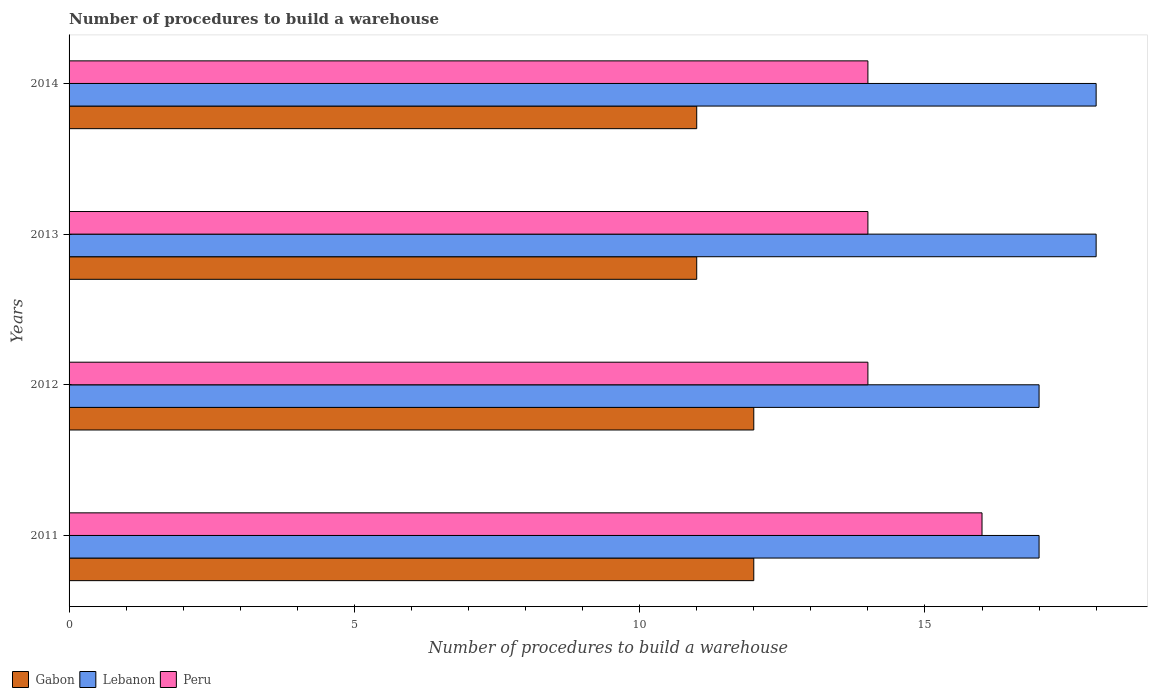How many different coloured bars are there?
Offer a terse response. 3. Are the number of bars per tick equal to the number of legend labels?
Offer a terse response. Yes. Are the number of bars on each tick of the Y-axis equal?
Your answer should be very brief. Yes. How many bars are there on the 3rd tick from the top?
Offer a very short reply. 3. How many bars are there on the 2nd tick from the bottom?
Make the answer very short. 3. What is the number of procedures to build a warehouse in in Gabon in 2012?
Offer a terse response. 12. Across all years, what is the maximum number of procedures to build a warehouse in in Gabon?
Offer a terse response. 12. Across all years, what is the minimum number of procedures to build a warehouse in in Lebanon?
Ensure brevity in your answer.  17. In which year was the number of procedures to build a warehouse in in Lebanon maximum?
Make the answer very short. 2013. In which year was the number of procedures to build a warehouse in in Gabon minimum?
Offer a very short reply. 2013. What is the total number of procedures to build a warehouse in in Lebanon in the graph?
Offer a very short reply. 70. What is the difference between the number of procedures to build a warehouse in in Lebanon in 2011 and that in 2013?
Make the answer very short. -1. What is the difference between the number of procedures to build a warehouse in in Lebanon in 2014 and the number of procedures to build a warehouse in in Peru in 2012?
Your response must be concise. 4. In the year 2013, what is the difference between the number of procedures to build a warehouse in in Lebanon and number of procedures to build a warehouse in in Gabon?
Provide a succinct answer. 7. In how many years, is the number of procedures to build a warehouse in in Gabon greater than 2 ?
Offer a very short reply. 4. What is the ratio of the number of procedures to build a warehouse in in Lebanon in 2013 to that in 2014?
Your answer should be compact. 1. Is the difference between the number of procedures to build a warehouse in in Lebanon in 2012 and 2013 greater than the difference between the number of procedures to build a warehouse in in Gabon in 2012 and 2013?
Your answer should be very brief. No. What is the difference between the highest and the lowest number of procedures to build a warehouse in in Gabon?
Keep it short and to the point. 1. In how many years, is the number of procedures to build a warehouse in in Lebanon greater than the average number of procedures to build a warehouse in in Lebanon taken over all years?
Offer a terse response. 2. Is the sum of the number of procedures to build a warehouse in in Peru in 2011 and 2013 greater than the maximum number of procedures to build a warehouse in in Gabon across all years?
Ensure brevity in your answer.  Yes. What does the 2nd bar from the top in 2012 represents?
Your response must be concise. Lebanon. How many bars are there?
Make the answer very short. 12. Are all the bars in the graph horizontal?
Provide a succinct answer. Yes. How many years are there in the graph?
Your answer should be compact. 4. What is the difference between two consecutive major ticks on the X-axis?
Your answer should be compact. 5. How are the legend labels stacked?
Your answer should be very brief. Horizontal. What is the title of the graph?
Make the answer very short. Number of procedures to build a warehouse. Does "Swaziland" appear as one of the legend labels in the graph?
Offer a terse response. No. What is the label or title of the X-axis?
Ensure brevity in your answer.  Number of procedures to build a warehouse. What is the Number of procedures to build a warehouse in Lebanon in 2013?
Provide a succinct answer. 18. What is the Number of procedures to build a warehouse of Peru in 2013?
Your response must be concise. 14. What is the Number of procedures to build a warehouse in Gabon in 2014?
Your response must be concise. 11. What is the Number of procedures to build a warehouse in Lebanon in 2014?
Provide a short and direct response. 18. Across all years, what is the maximum Number of procedures to build a warehouse in Gabon?
Make the answer very short. 12. Across all years, what is the minimum Number of procedures to build a warehouse of Gabon?
Your answer should be very brief. 11. Across all years, what is the minimum Number of procedures to build a warehouse in Peru?
Ensure brevity in your answer.  14. What is the difference between the Number of procedures to build a warehouse of Lebanon in 2011 and that in 2012?
Ensure brevity in your answer.  0. What is the difference between the Number of procedures to build a warehouse of Peru in 2011 and that in 2012?
Ensure brevity in your answer.  2. What is the difference between the Number of procedures to build a warehouse in Gabon in 2011 and that in 2013?
Offer a terse response. 1. What is the difference between the Number of procedures to build a warehouse in Lebanon in 2011 and that in 2013?
Your answer should be very brief. -1. What is the difference between the Number of procedures to build a warehouse of Peru in 2011 and that in 2013?
Keep it short and to the point. 2. What is the difference between the Number of procedures to build a warehouse of Lebanon in 2011 and that in 2014?
Offer a terse response. -1. What is the difference between the Number of procedures to build a warehouse of Lebanon in 2012 and that in 2013?
Keep it short and to the point. -1. What is the difference between the Number of procedures to build a warehouse of Peru in 2012 and that in 2013?
Provide a succinct answer. 0. What is the difference between the Number of procedures to build a warehouse in Lebanon in 2012 and that in 2014?
Keep it short and to the point. -1. What is the difference between the Number of procedures to build a warehouse in Peru in 2012 and that in 2014?
Offer a terse response. 0. What is the difference between the Number of procedures to build a warehouse in Gabon in 2013 and that in 2014?
Ensure brevity in your answer.  0. What is the difference between the Number of procedures to build a warehouse of Lebanon in 2013 and that in 2014?
Ensure brevity in your answer.  0. What is the difference between the Number of procedures to build a warehouse of Gabon in 2011 and the Number of procedures to build a warehouse of Lebanon in 2013?
Offer a terse response. -6. What is the difference between the Number of procedures to build a warehouse of Gabon in 2011 and the Number of procedures to build a warehouse of Peru in 2013?
Offer a terse response. -2. What is the difference between the Number of procedures to build a warehouse of Lebanon in 2012 and the Number of procedures to build a warehouse of Peru in 2013?
Your answer should be very brief. 3. What is the difference between the Number of procedures to build a warehouse of Lebanon in 2012 and the Number of procedures to build a warehouse of Peru in 2014?
Offer a very short reply. 3. What is the difference between the Number of procedures to build a warehouse in Gabon in 2013 and the Number of procedures to build a warehouse in Lebanon in 2014?
Make the answer very short. -7. In the year 2011, what is the difference between the Number of procedures to build a warehouse in Gabon and Number of procedures to build a warehouse in Lebanon?
Your response must be concise. -5. In the year 2012, what is the difference between the Number of procedures to build a warehouse of Gabon and Number of procedures to build a warehouse of Lebanon?
Your response must be concise. -5. In the year 2012, what is the difference between the Number of procedures to build a warehouse in Lebanon and Number of procedures to build a warehouse in Peru?
Ensure brevity in your answer.  3. In the year 2013, what is the difference between the Number of procedures to build a warehouse of Lebanon and Number of procedures to build a warehouse of Peru?
Give a very brief answer. 4. In the year 2014, what is the difference between the Number of procedures to build a warehouse of Gabon and Number of procedures to build a warehouse of Peru?
Your response must be concise. -3. In the year 2014, what is the difference between the Number of procedures to build a warehouse of Lebanon and Number of procedures to build a warehouse of Peru?
Ensure brevity in your answer.  4. What is the ratio of the Number of procedures to build a warehouse of Lebanon in 2011 to that in 2012?
Ensure brevity in your answer.  1. What is the ratio of the Number of procedures to build a warehouse in Gabon in 2011 to that in 2013?
Keep it short and to the point. 1.09. What is the ratio of the Number of procedures to build a warehouse in Lebanon in 2011 to that in 2013?
Keep it short and to the point. 0.94. What is the ratio of the Number of procedures to build a warehouse in Peru in 2011 to that in 2014?
Provide a succinct answer. 1.14. What is the ratio of the Number of procedures to build a warehouse of Peru in 2012 to that in 2013?
Offer a terse response. 1. What is the ratio of the Number of procedures to build a warehouse in Peru in 2012 to that in 2014?
Your answer should be very brief. 1. What is the ratio of the Number of procedures to build a warehouse in Gabon in 2013 to that in 2014?
Your answer should be compact. 1. What is the ratio of the Number of procedures to build a warehouse of Peru in 2013 to that in 2014?
Your answer should be compact. 1. What is the difference between the highest and the second highest Number of procedures to build a warehouse of Peru?
Keep it short and to the point. 2. 